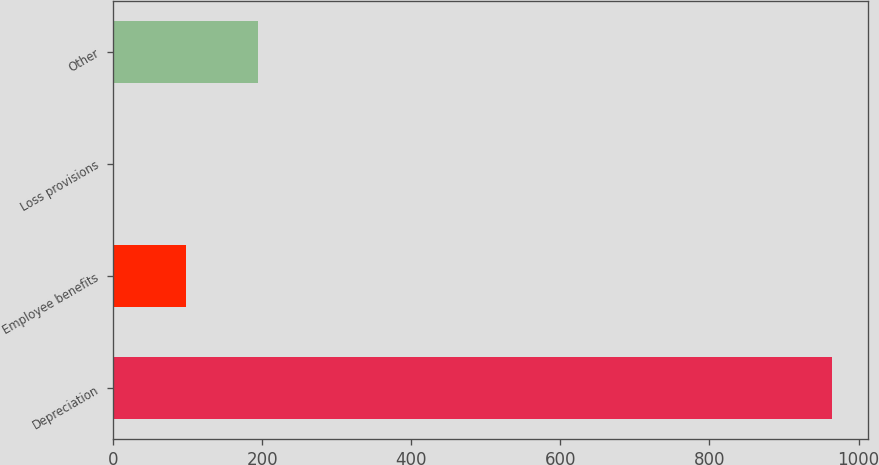Convert chart. <chart><loc_0><loc_0><loc_500><loc_500><bar_chart><fcel>Depreciation<fcel>Employee benefits<fcel>Loss provisions<fcel>Other<nl><fcel>964<fcel>98.2<fcel>2<fcel>194.4<nl></chart> 